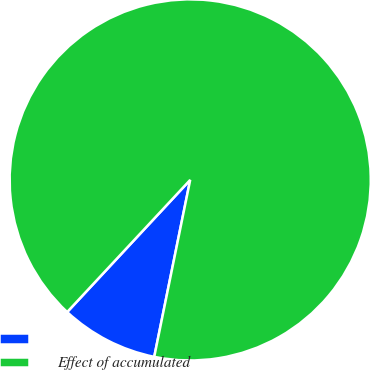Convert chart to OTSL. <chart><loc_0><loc_0><loc_500><loc_500><pie_chart><ecel><fcel>Effect of accumulated<nl><fcel>8.74%<fcel>91.26%<nl></chart> 